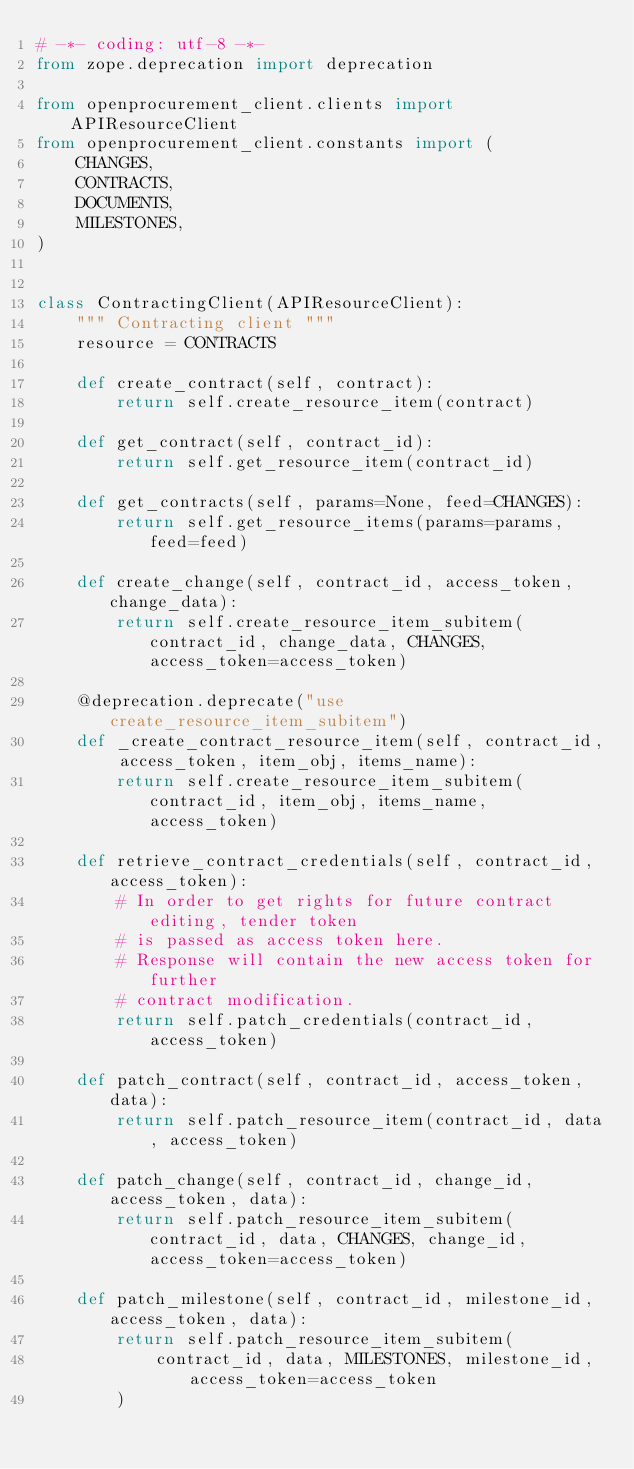<code> <loc_0><loc_0><loc_500><loc_500><_Python_># -*- coding: utf-8 -*-
from zope.deprecation import deprecation

from openprocurement_client.clients import APIResourceClient
from openprocurement_client.constants import (
    CHANGES,
    CONTRACTS,
    DOCUMENTS,
    MILESTONES,
)


class ContractingClient(APIResourceClient):
    """ Contracting client """
    resource = CONTRACTS

    def create_contract(self, contract):
        return self.create_resource_item(contract)

    def get_contract(self, contract_id):
        return self.get_resource_item(contract_id)

    def get_contracts(self, params=None, feed=CHANGES):
        return self.get_resource_items(params=params, feed=feed)

    def create_change(self, contract_id, access_token, change_data):
        return self.create_resource_item_subitem(contract_id, change_data, CHANGES, access_token=access_token)

    @deprecation.deprecate("use create_resource_item_subitem")
    def _create_contract_resource_item(self, contract_id, access_token, item_obj, items_name):
        return self.create_resource_item_subitem(contract_id, item_obj, items_name, access_token)

    def retrieve_contract_credentials(self, contract_id, access_token):
        # In order to get rights for future contract editing, tender token
        # is passed as access token here.
        # Response will contain the new access token for further
        # contract modification.
        return self.patch_credentials(contract_id, access_token)

    def patch_contract(self, contract_id, access_token, data):
        return self.patch_resource_item(contract_id, data, access_token)

    def patch_change(self, contract_id, change_id, access_token, data):
        return self.patch_resource_item_subitem(contract_id, data, CHANGES, change_id, access_token=access_token)

    def patch_milestone(self, contract_id, milestone_id, access_token, data):
        return self.patch_resource_item_subitem(
            contract_id, data, MILESTONES, milestone_id, access_token=access_token
        )
</code> 